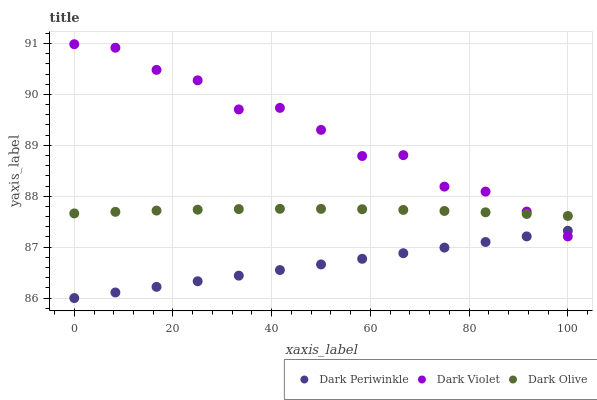Does Dark Periwinkle have the minimum area under the curve?
Answer yes or no. Yes. Does Dark Violet have the maximum area under the curve?
Answer yes or no. Yes. Does Dark Violet have the minimum area under the curve?
Answer yes or no. No. Does Dark Periwinkle have the maximum area under the curve?
Answer yes or no. No. Is Dark Periwinkle the smoothest?
Answer yes or no. Yes. Is Dark Violet the roughest?
Answer yes or no. Yes. Is Dark Violet the smoothest?
Answer yes or no. No. Is Dark Periwinkle the roughest?
Answer yes or no. No. Does Dark Periwinkle have the lowest value?
Answer yes or no. Yes. Does Dark Violet have the lowest value?
Answer yes or no. No. Does Dark Violet have the highest value?
Answer yes or no. Yes. Does Dark Periwinkle have the highest value?
Answer yes or no. No. Is Dark Periwinkle less than Dark Olive?
Answer yes or no. Yes. Is Dark Olive greater than Dark Periwinkle?
Answer yes or no. Yes. Does Dark Violet intersect Dark Periwinkle?
Answer yes or no. Yes. Is Dark Violet less than Dark Periwinkle?
Answer yes or no. No. Is Dark Violet greater than Dark Periwinkle?
Answer yes or no. No. Does Dark Periwinkle intersect Dark Olive?
Answer yes or no. No. 